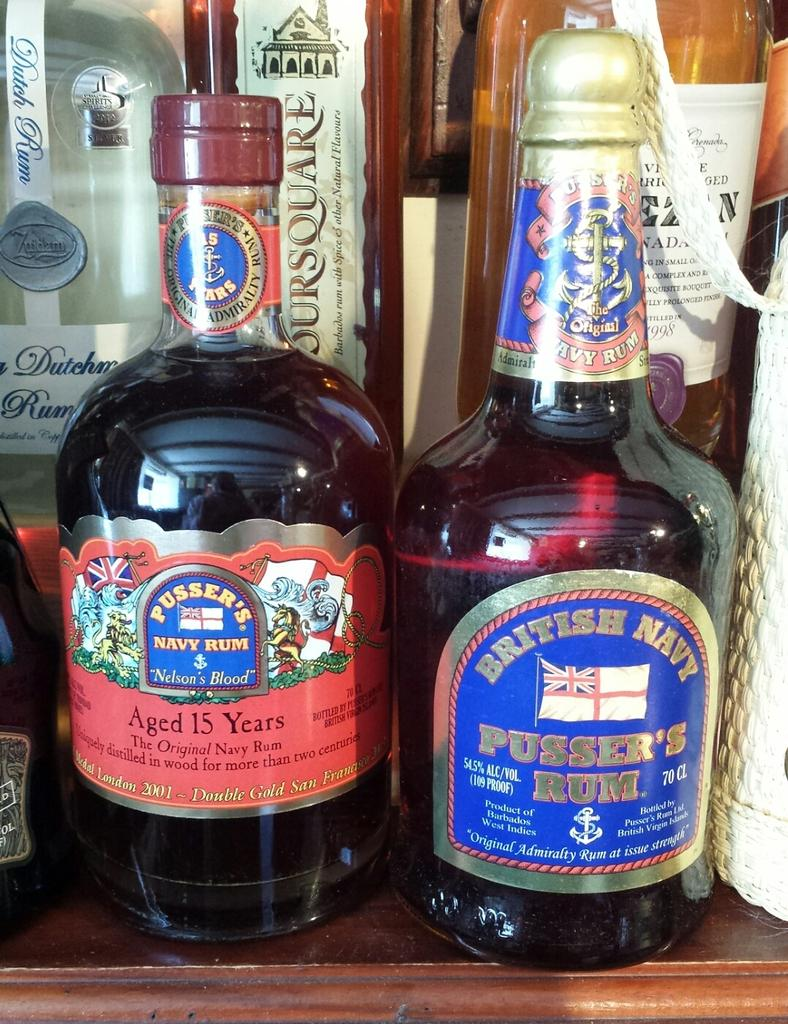Provide a one-sentence caption for the provided image. two bottles of alchohol, pusser's navy rum and british navy pusser's rum. 